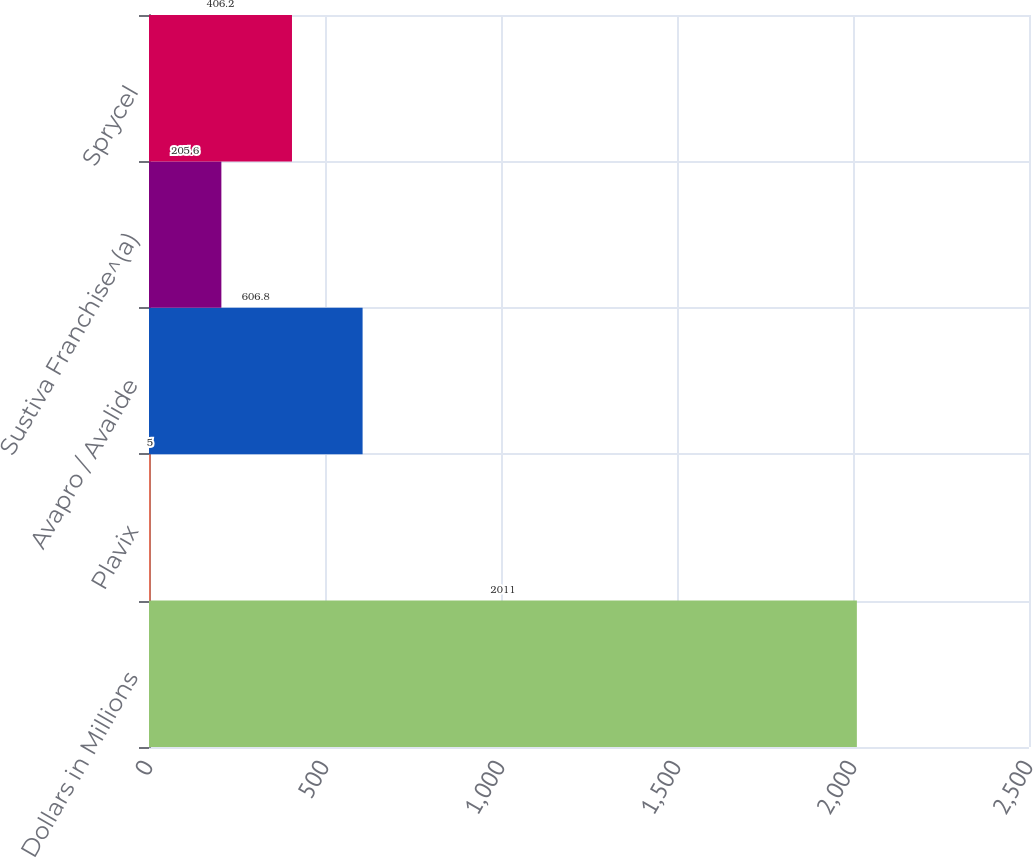Convert chart. <chart><loc_0><loc_0><loc_500><loc_500><bar_chart><fcel>Dollars in Millions<fcel>Plavix<fcel>Avapro / Avalide<fcel>Sustiva Franchise^(a)<fcel>Sprycel<nl><fcel>2011<fcel>5<fcel>606.8<fcel>205.6<fcel>406.2<nl></chart> 